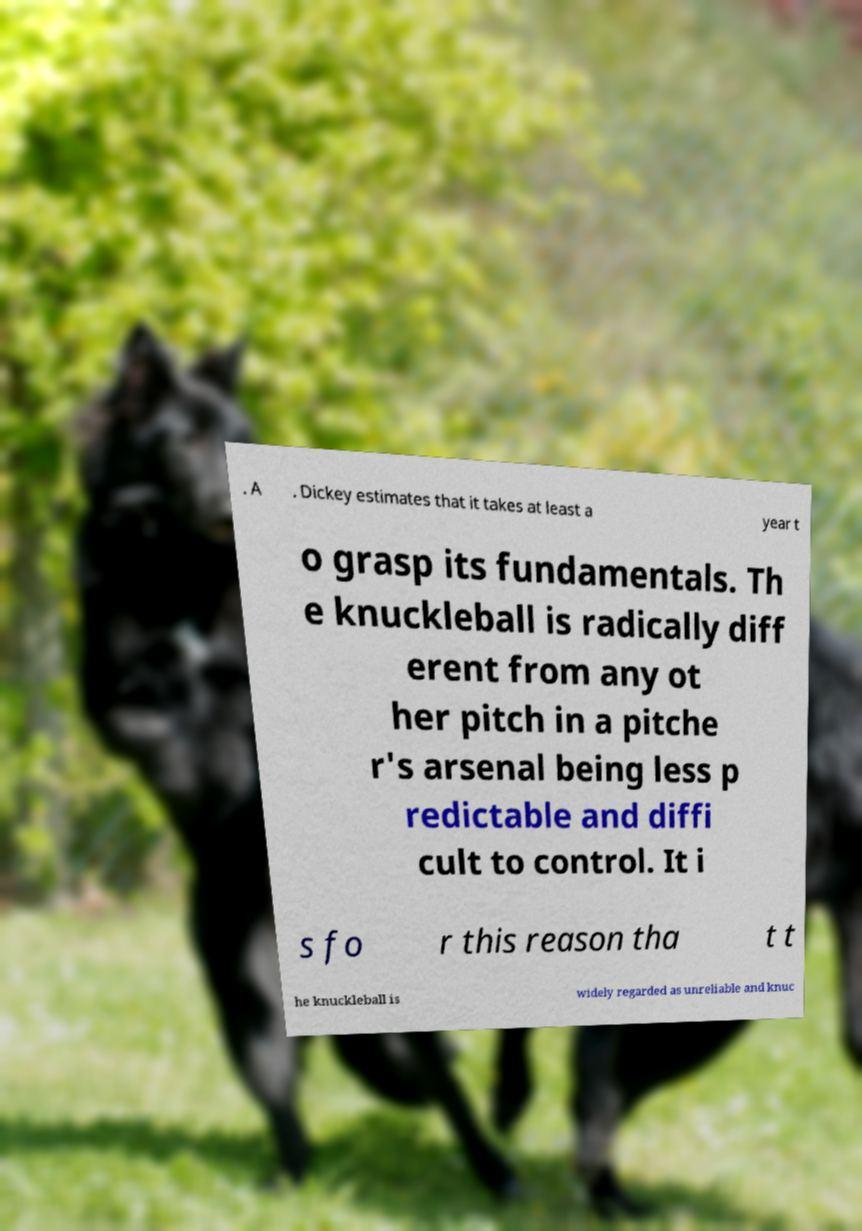I need the written content from this picture converted into text. Can you do that? . A . Dickey estimates that it takes at least a year t o grasp its fundamentals. Th e knuckleball is radically diff erent from any ot her pitch in a pitche r's arsenal being less p redictable and diffi cult to control. It i s fo r this reason tha t t he knuckleball is widely regarded as unreliable and knuc 